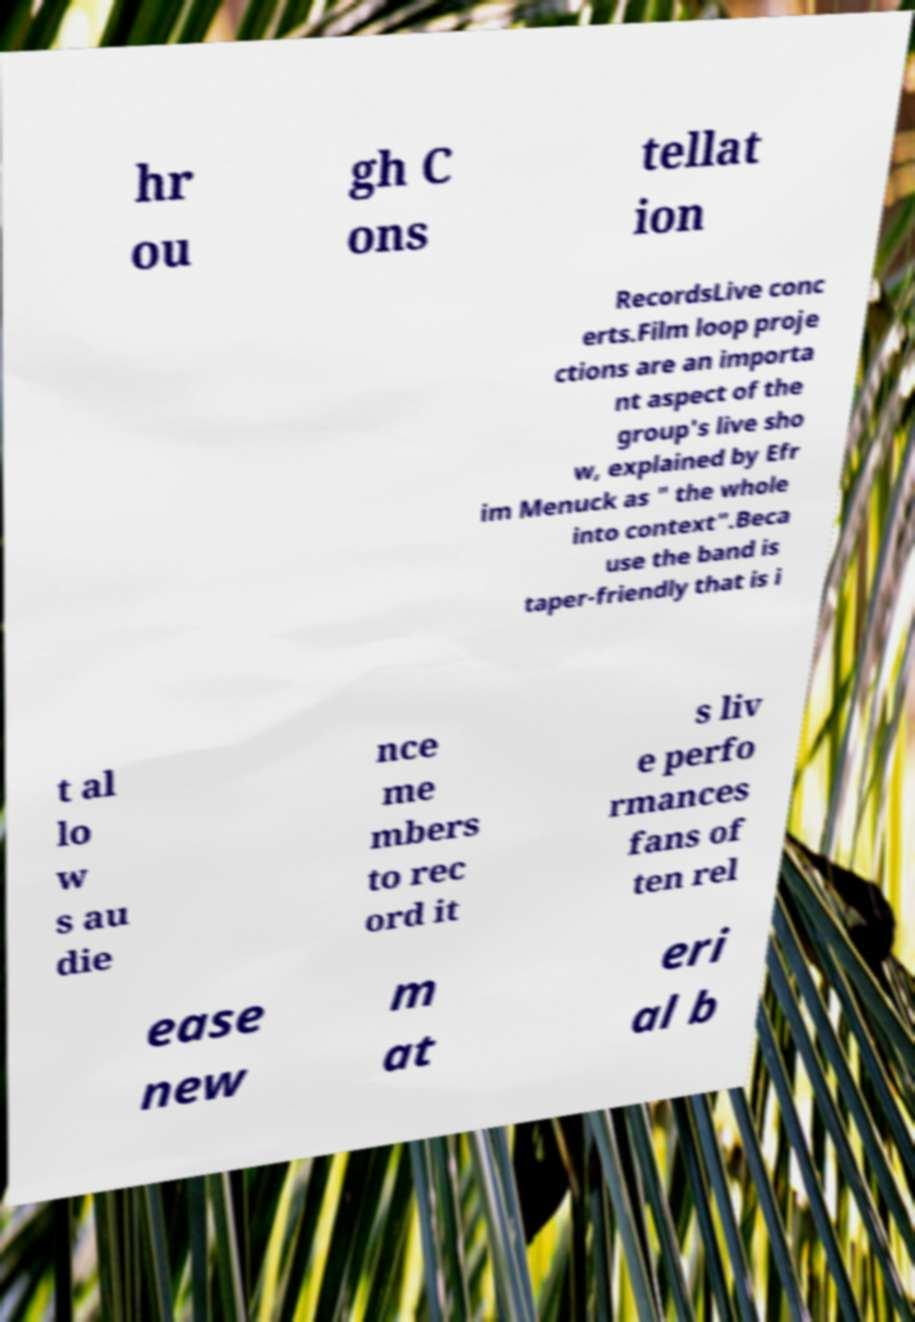Please read and relay the text visible in this image. What does it say? hr ou gh C ons tellat ion RecordsLive conc erts.Film loop proje ctions are an importa nt aspect of the group's live sho w, explained by Efr im Menuck as " the whole into context".Beca use the band is taper-friendly that is i t al lo w s au die nce me mbers to rec ord it s liv e perfo rmances fans of ten rel ease new m at eri al b 